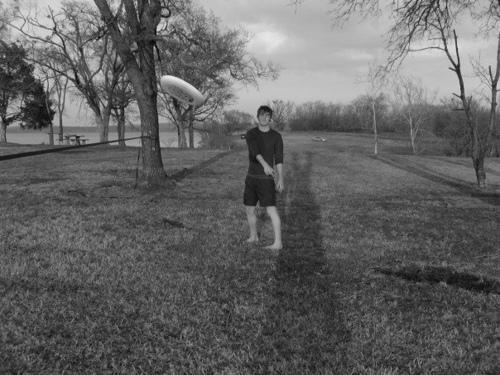How many kites are in the image?
Give a very brief answer. 0. How many children are at the playground?
Give a very brief answer. 1. 